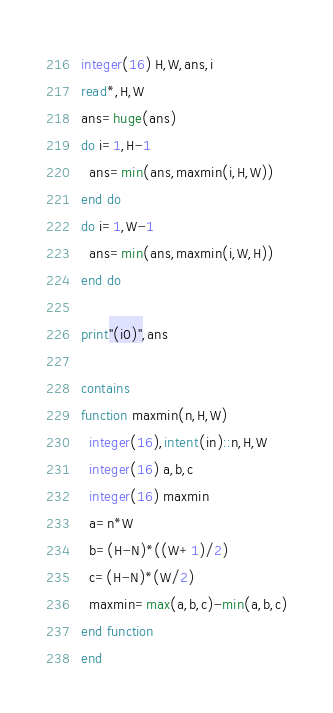Convert code to text. <code><loc_0><loc_0><loc_500><loc_500><_FORTRAN_>integer(16) H,W,ans,i
read*,H,W
ans=huge(ans)
do i=1,H-1
  ans=min(ans,maxmin(i,H,W))
end do
do i=1,W-1
  ans=min(ans,maxmin(i,W,H))
end do

print"(i0)",ans

contains
function maxmin(n,H,W)
  integer(16),intent(in)::n,H,W
  integer(16) a,b,c
  integer(16) maxmin
  a=n*W
  b=(H-N)*((W+1)/2)
  c=(H-N)*(W/2)
  maxmin=max(a,b,c)-min(a,b,c)
end function
end</code> 